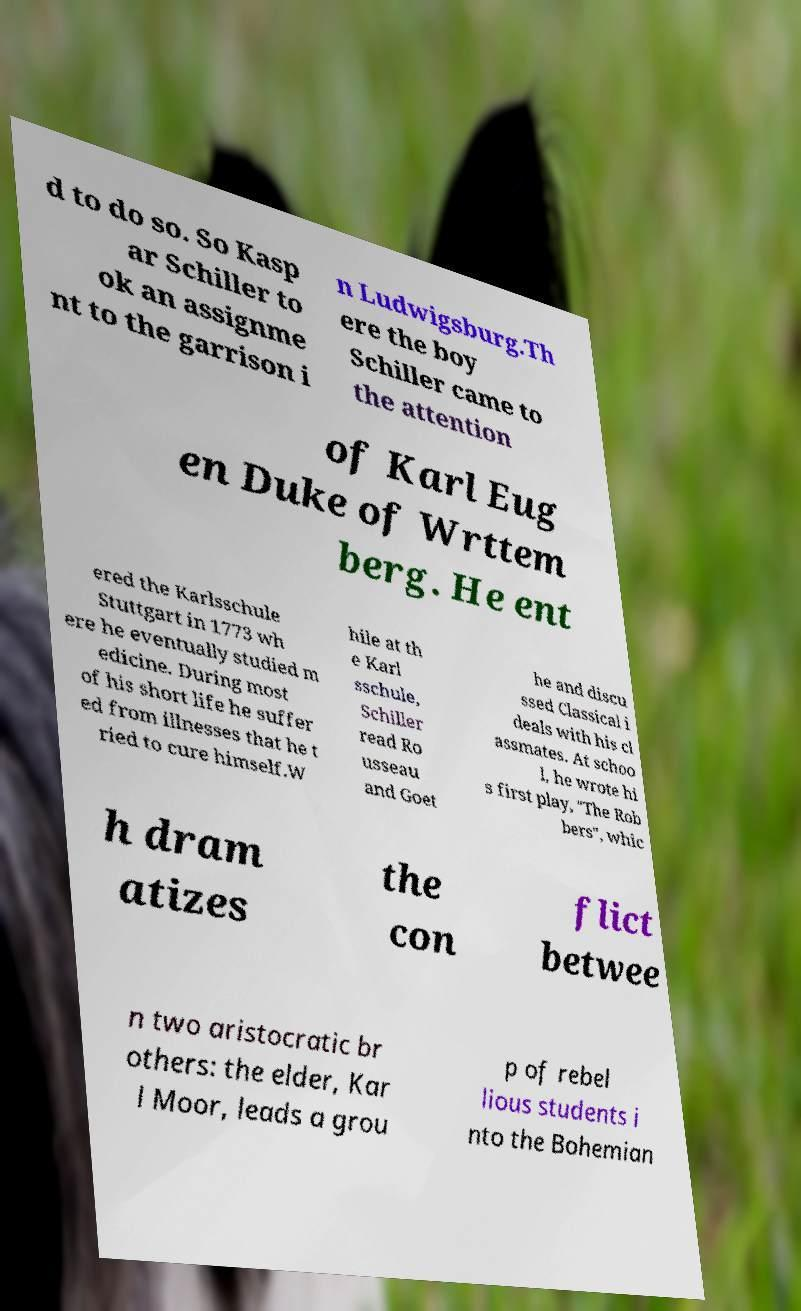Please read and relay the text visible in this image. What does it say? d to do so. So Kasp ar Schiller to ok an assignme nt to the garrison i n Ludwigsburg.Th ere the boy Schiller came to the attention of Karl Eug en Duke of Wrttem berg. He ent ered the Karlsschule Stuttgart in 1773 wh ere he eventually studied m edicine. During most of his short life he suffer ed from illnesses that he t ried to cure himself.W hile at th e Karl sschule, Schiller read Ro usseau and Goet he and discu ssed Classical i deals with his cl assmates. At schoo l, he wrote hi s first play, "The Rob bers", whic h dram atizes the con flict betwee n two aristocratic br others: the elder, Kar l Moor, leads a grou p of rebel lious students i nto the Bohemian 